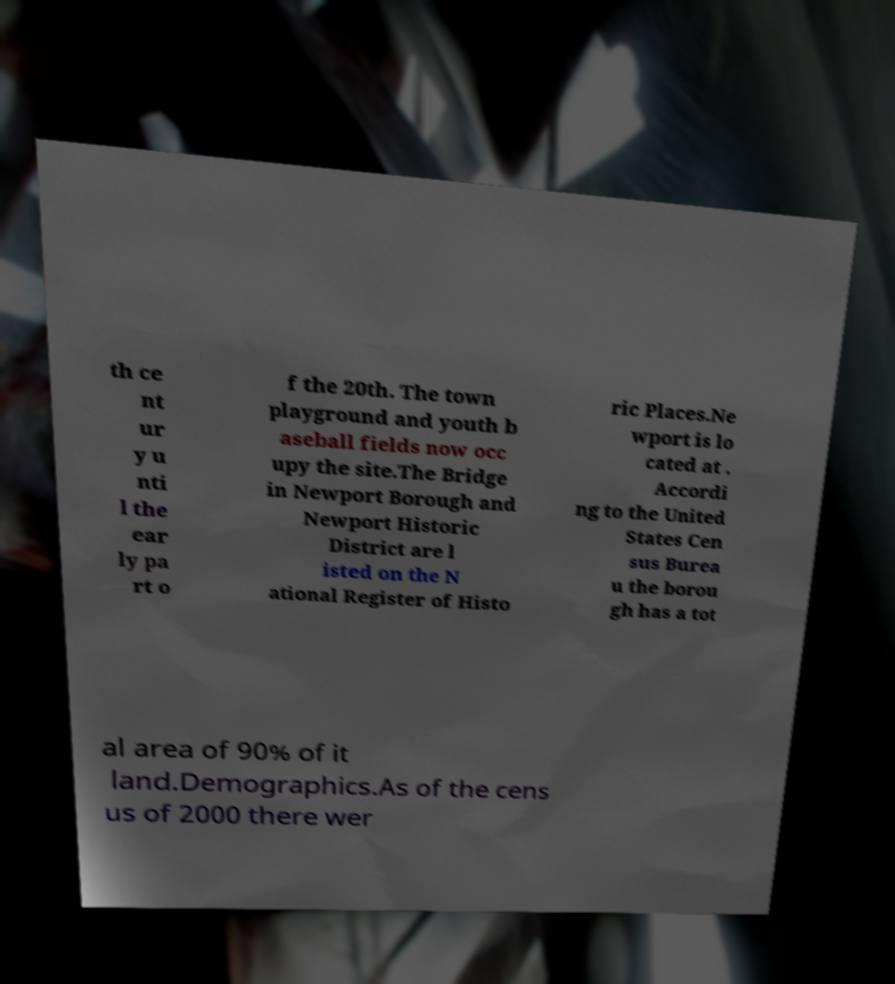Could you assist in decoding the text presented in this image and type it out clearly? th ce nt ur y u nti l the ear ly pa rt o f the 20th. The town playground and youth b aseball fields now occ upy the site.The Bridge in Newport Borough and Newport Historic District are l isted on the N ational Register of Histo ric Places.Ne wport is lo cated at . Accordi ng to the United States Cen sus Burea u the borou gh has a tot al area of 90% of it land.Demographics.As of the cens us of 2000 there wer 